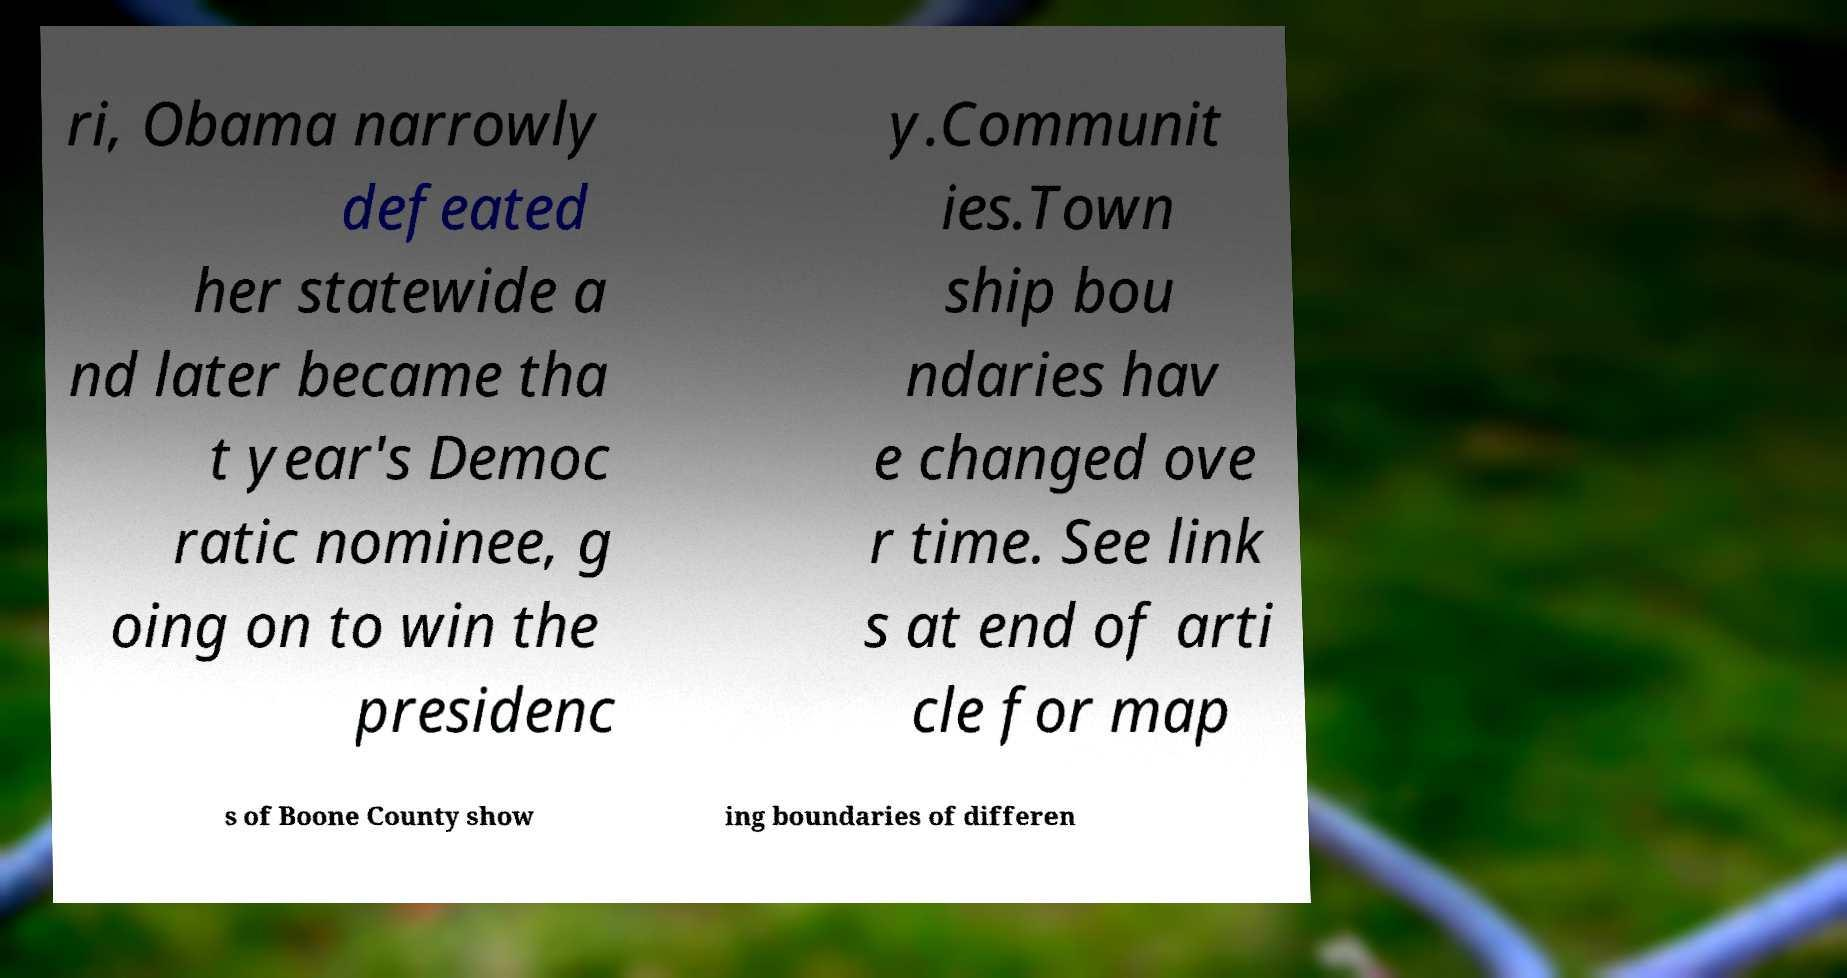Please identify and transcribe the text found in this image. ri, Obama narrowly defeated her statewide a nd later became tha t year's Democ ratic nominee, g oing on to win the presidenc y.Communit ies.Town ship bou ndaries hav e changed ove r time. See link s at end of arti cle for map s of Boone County show ing boundaries of differen 